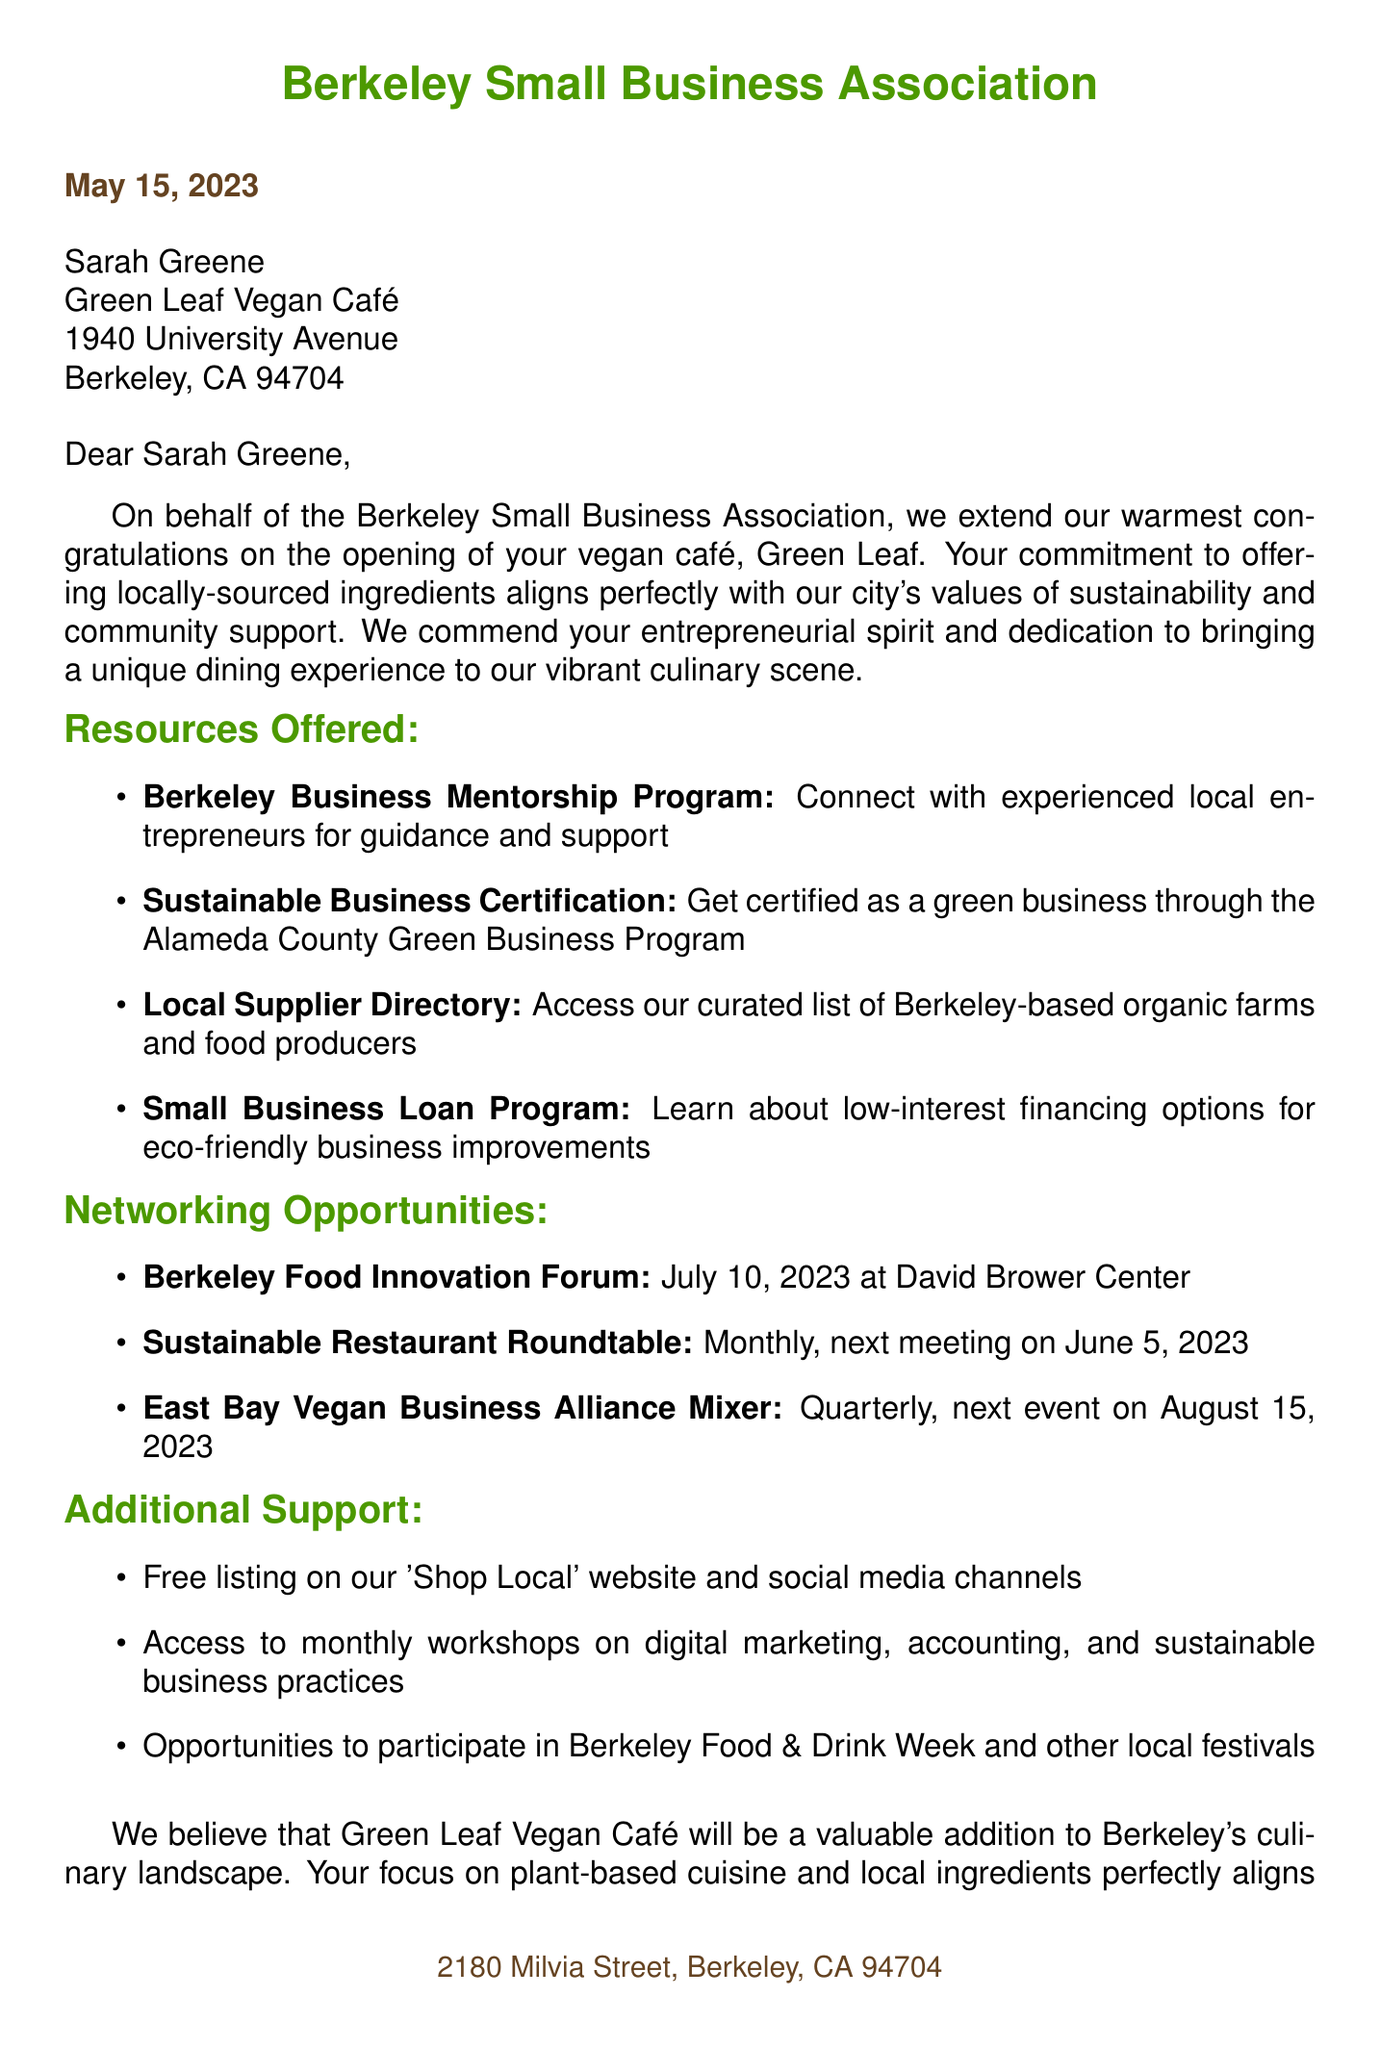What is the name of the recipient? The document states that the recipient is "Sarah Greene."
Answer: Sarah Greene What is the business name? The letter mentions the business as "Green Leaf Vegan Café."
Answer: Green Leaf Vegan Café What is the address of the business? The address stated in the document is "1940 University Avenue, Berkeley, CA 94704."
Answer: 1940 University Avenue, Berkeley, CA 94704 What is the date of the letter? The letter is dated "May 15, 2023."
Answer: May 15, 2023 What type of assistance is offered through the Berkeley Business Mentorship Program? The document describes it as "Connect with experienced local entrepreneurs for guidance and support."
Answer: Connect with experienced local entrepreneurs for guidance and support How often does the Sustainable Restaurant Roundtable meet? The letter states that it is a "Monthly" event.
Answer: Monthly When is the next East Bay Vegan Business Alliance Mixer? The document specifies that it will be on "August 15, 2023."
Answer: August 15, 2023 Who is the president of the Berkeley Small Business Association? The letter indicates that the president is "Michael Chen."
Answer: Michael Chen What support is provided for marketing assistance? The document mentions "Free listing on our 'Shop Local' website and social media channels."
Answer: Free listing on our 'Shop Local' website and social media channels 